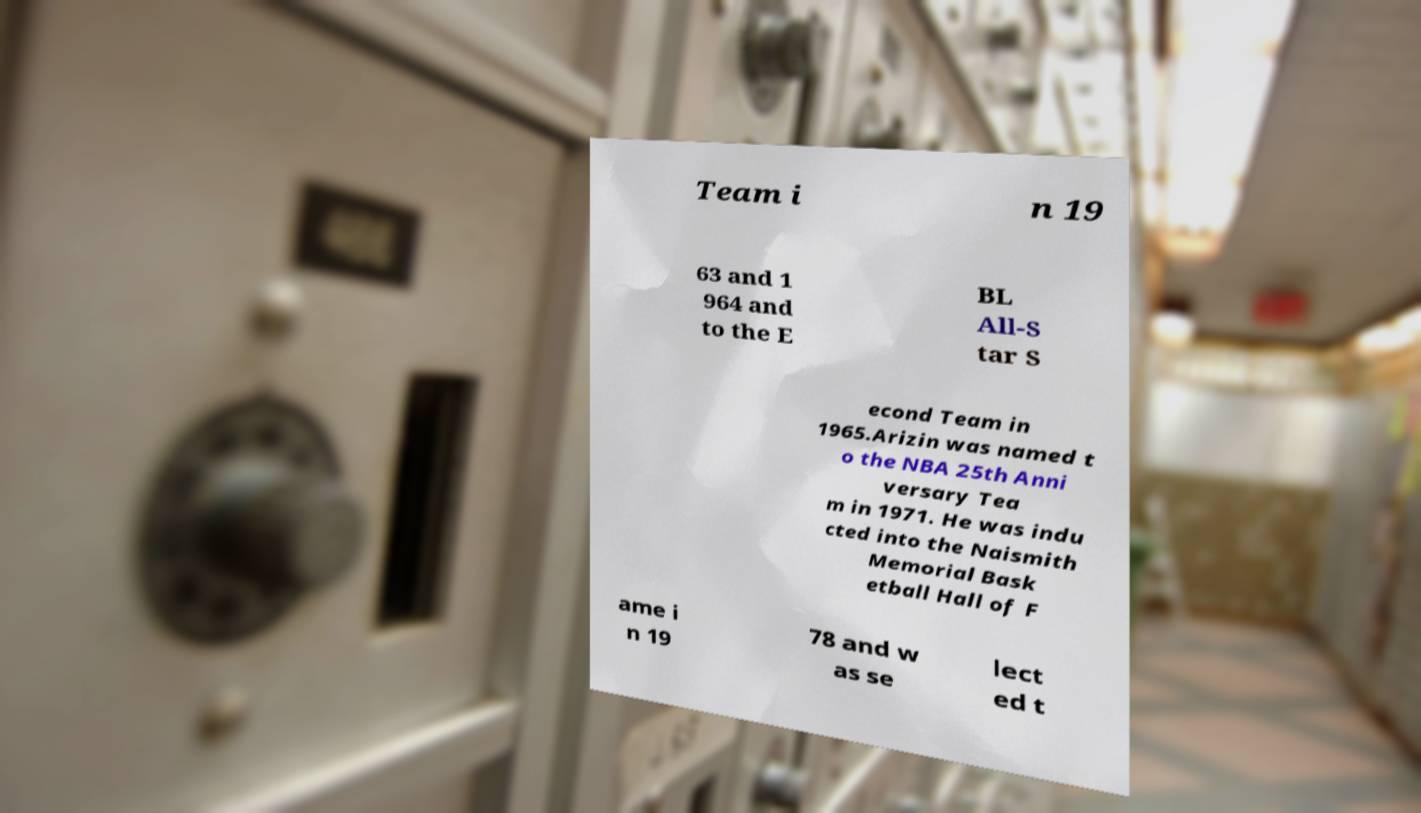There's text embedded in this image that I need extracted. Can you transcribe it verbatim? Team i n 19 63 and 1 964 and to the E BL All-S tar S econd Team in 1965.Arizin was named t o the NBA 25th Anni versary Tea m in 1971. He was indu cted into the Naismith Memorial Bask etball Hall of F ame i n 19 78 and w as se lect ed t 